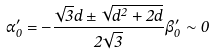<formula> <loc_0><loc_0><loc_500><loc_500>\alpha _ { 0 } ^ { \prime } = - \frac { \sqrt { 3 } d \pm \sqrt { d ^ { 2 } + 2 d } } { 2 \sqrt { 3 } } \beta _ { 0 } ^ { \prime } \sim 0</formula> 